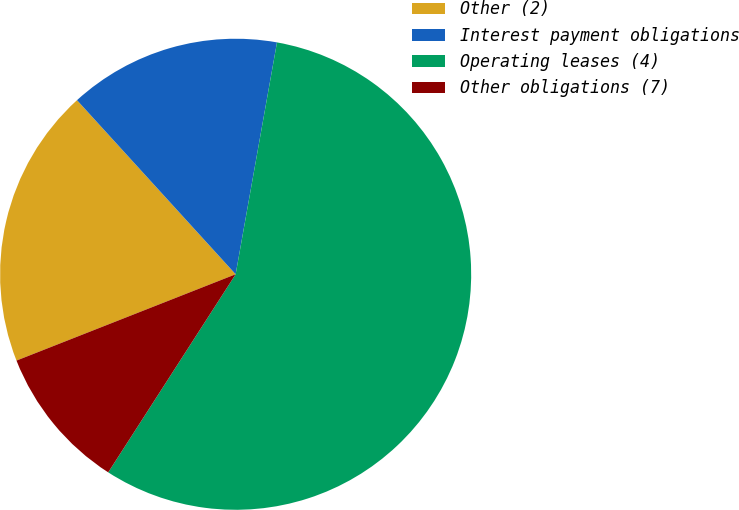Convert chart. <chart><loc_0><loc_0><loc_500><loc_500><pie_chart><fcel>Other (2)<fcel>Interest payment obligations<fcel>Operating leases (4)<fcel>Other obligations (7)<nl><fcel>19.21%<fcel>14.57%<fcel>56.29%<fcel>9.93%<nl></chart> 